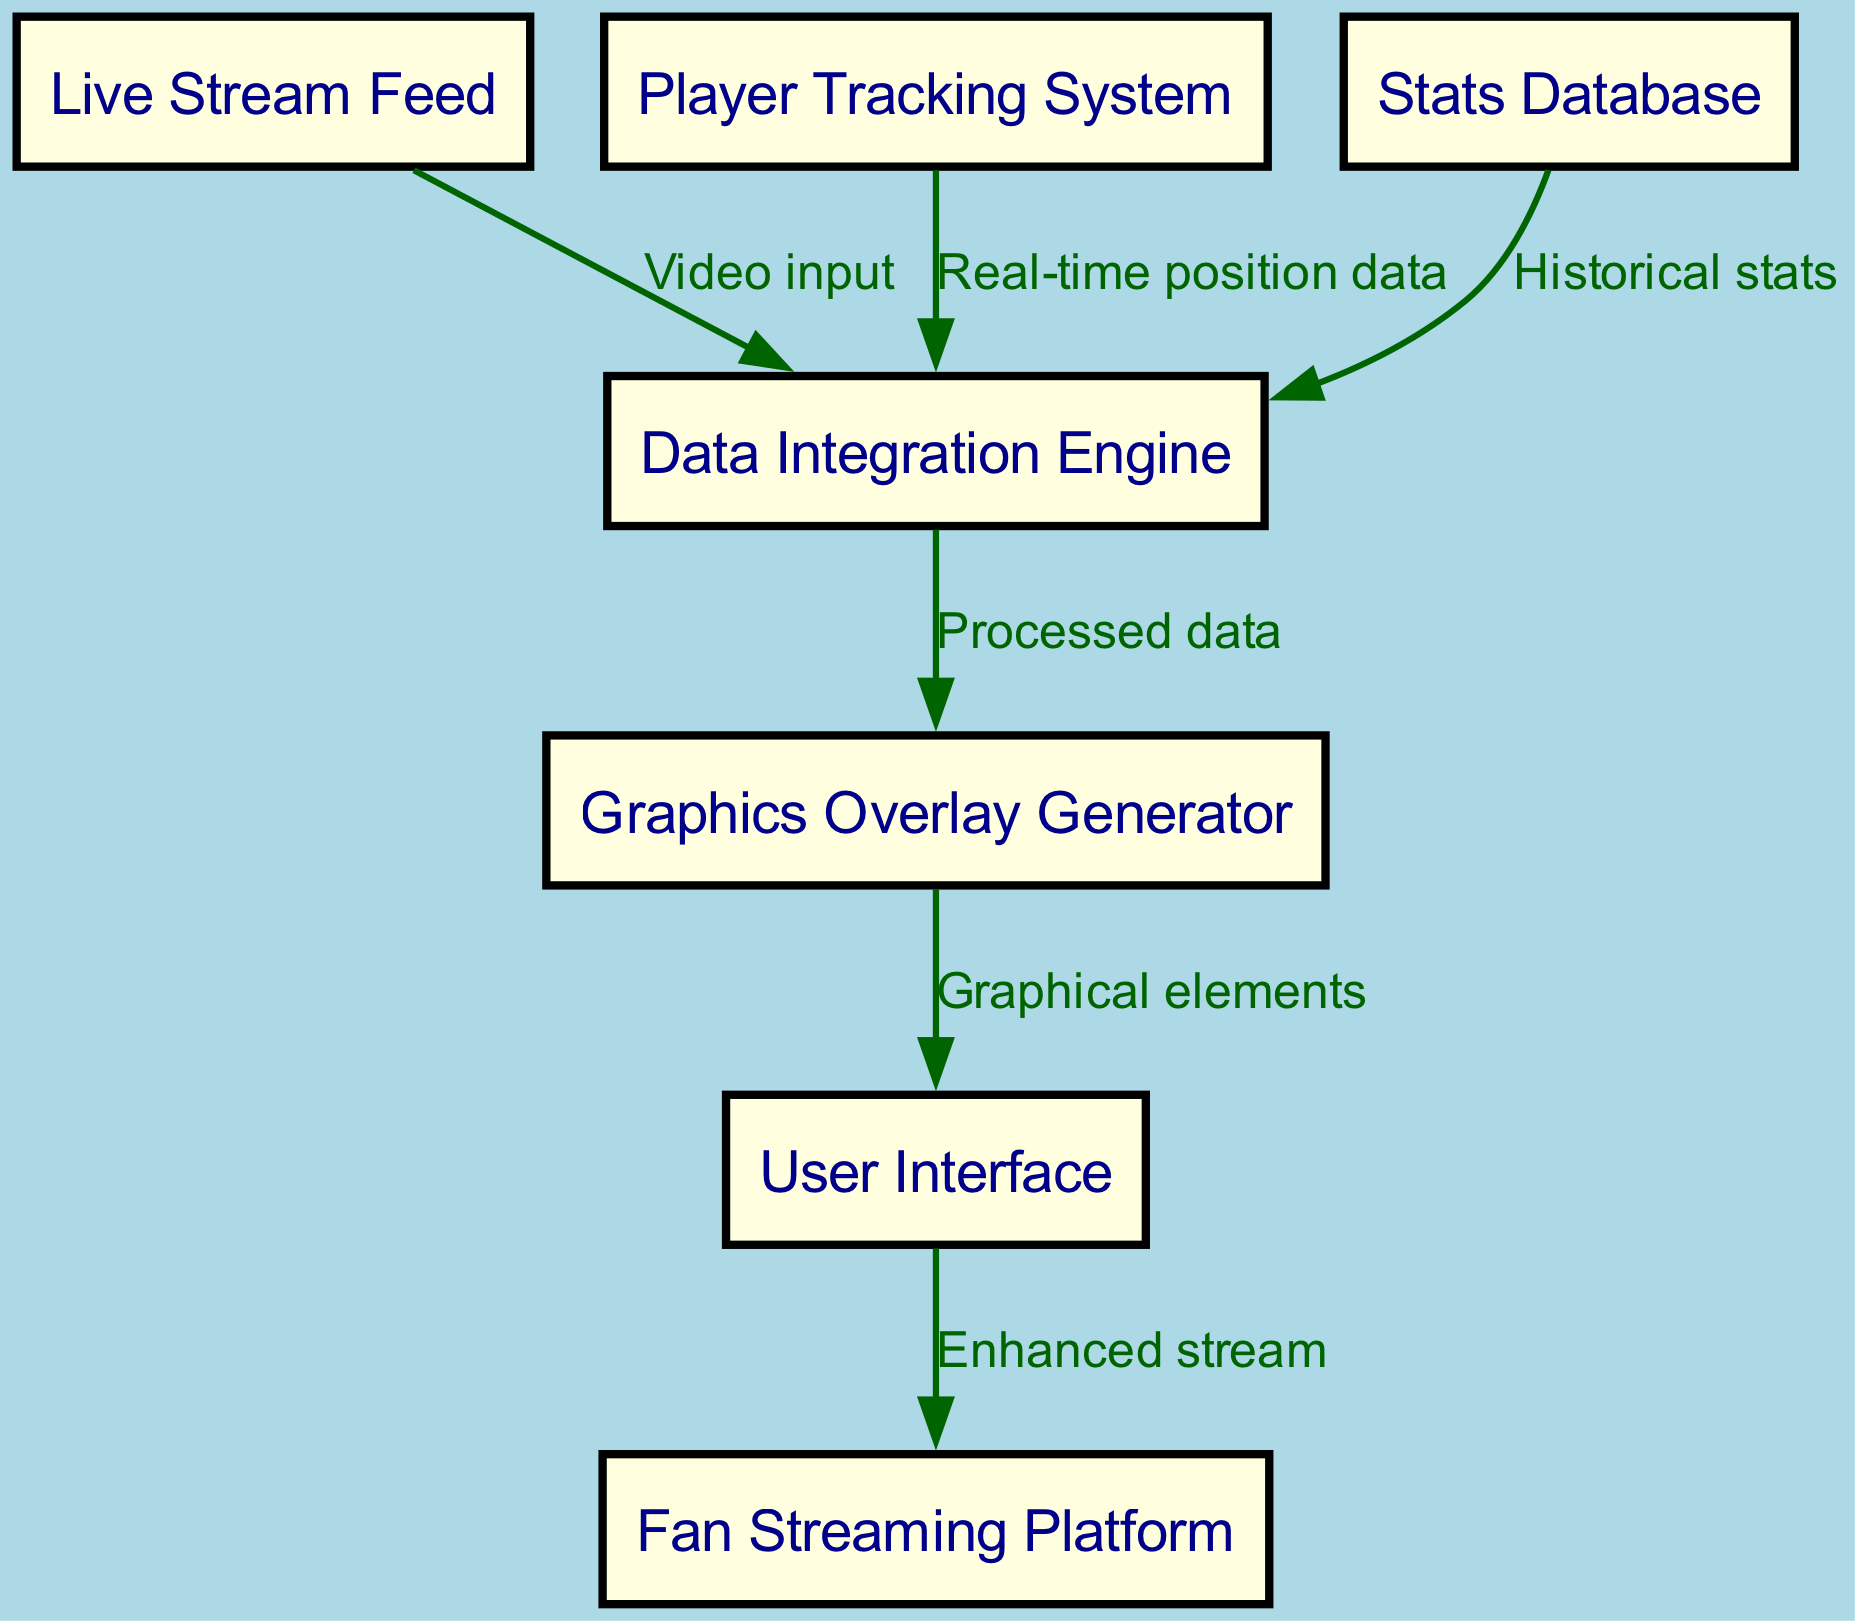What is the starting point of the data flow? The diagram indicates that the data flow begins at the "Live Stream Feed" node. This is the first node, meaning it serves as the initial source of information entering the integration process.
Answer: Live Stream Feed How many nodes are in the diagram? By counting all the distinct nodes labeled in the diagram, we find there are seven nodes present: Live Stream Feed, Player Tracking System, Stats Database, Data Integration Engine, Graphics Overlay Generator, User Interface, and Fan Streaming Platform.
Answer: 7 What type of data does the Player Tracking System provide? According to the arrow labeled "Real-time position data" connecting the Player Tracking System to the Data Integration Engine, this indicates that the Player Tracking System supplies real-time positional information as its output.
Answer: Real-time position data Which node receives processed data? By following the edges from the Data Integration Engine, we see it outputs "Processed data" to the Graphics Overlay Generator, thus making the Graphics Overlay Generator the node that receives this processed data.
Answer: Graphics Overlay Generator What is the final output of the entire integration process? Tracing the flow, the last node receiving data is the "Fan Streaming Platform," which gets the "Enhanced stream" from the User Interface. This signifies that the entire process culminates in an enhanced streaming experience for fans.
Answer: Fan Streaming Platform How many edges are present in the diagram? The edges, which represent the connections and relationships between nodes, total six in this diagram: Live Stream Feed to Data Integration Engine, Player Tracking System to Data Integration Engine, Stats Database to Data Integration Engine, Data Integration Engine to Graphics Overlay Generator, Graphics Overlay Generator to User Interface, and User Interface to Fan Streaming Platform.
Answer: 6 What does the User Interface provide to the Fan Streaming Platform? The diagram shows that the User Interface sends "Enhanced stream" to the Fan Streaming Platform, indicating that it is the final step in delivering an upgraded streaming experience to the fans.
Answer: Enhanced stream Which nodes send input to the Data Integration Engine? The Data Integration Engine receives inputs from three nodes: the Live Stream Feed, the Player Tracking System, and the Stats Database, as indicated by the incoming edges connected to it.
Answer: Live Stream Feed, Player Tracking System, Stats Database 